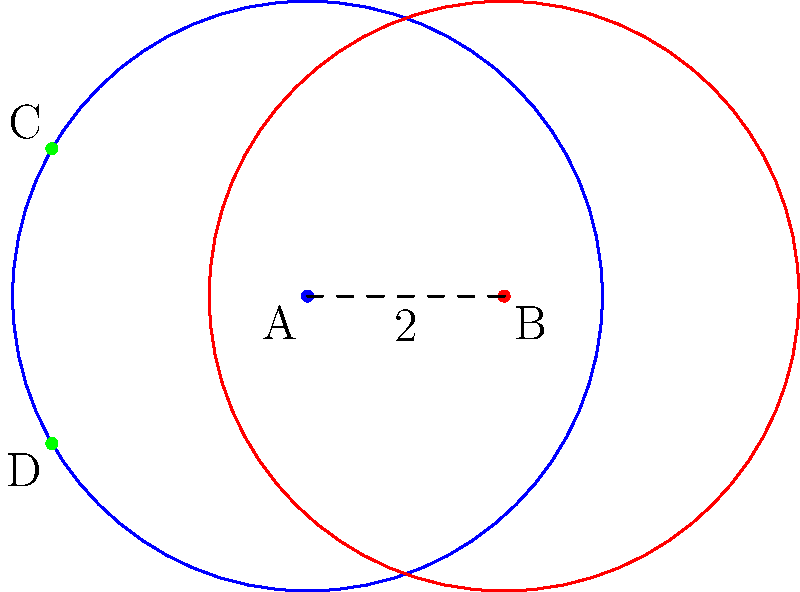In a modern basketball analysis, two overlapping circular zones on the court are represented by the equations $(x)^2 + y^2 = 9$ and $(x-2)^2 + y^2 = 9$. Find the coordinates of the intersection points of these two zones. Let's approach this step-by-step:

1) The equations of the two circles are:
   Circle 1: $x^2 + y^2 = 9$
   Circle 2: $(x-2)^2 + y^2 = 9$

2) To find the intersection points, we need to solve these equations simultaneously.

3) Expand the second equation:
   $x^2 - 4x + 4 + y^2 = 9$

4) Subtract the first equation from the expanded second equation:
   $(x^2 - 4x + 4 + y^2 = 9) - (x^2 + y^2 = 9)$
   $-4x + 4 = 0$

5) Solve this equation:
   $-4x = -4$
   $x = 1$

6) Substitute this x-value back into either of the original equations. Let's use the first one:
   $1^2 + y^2 = 9$
   $y^2 = 8$
   $y = \pm \sqrt{8} = \pm 2\sqrt{2}$

7) Therefore, the intersection points are:
   $(1, 2\sqrt{2})$ and $(1, -2\sqrt{2})$

These points represent where the two circular zones overlap on the basketball court.
Answer: $(1, 2\sqrt{2})$ and $(1, -2\sqrt{2})$ 